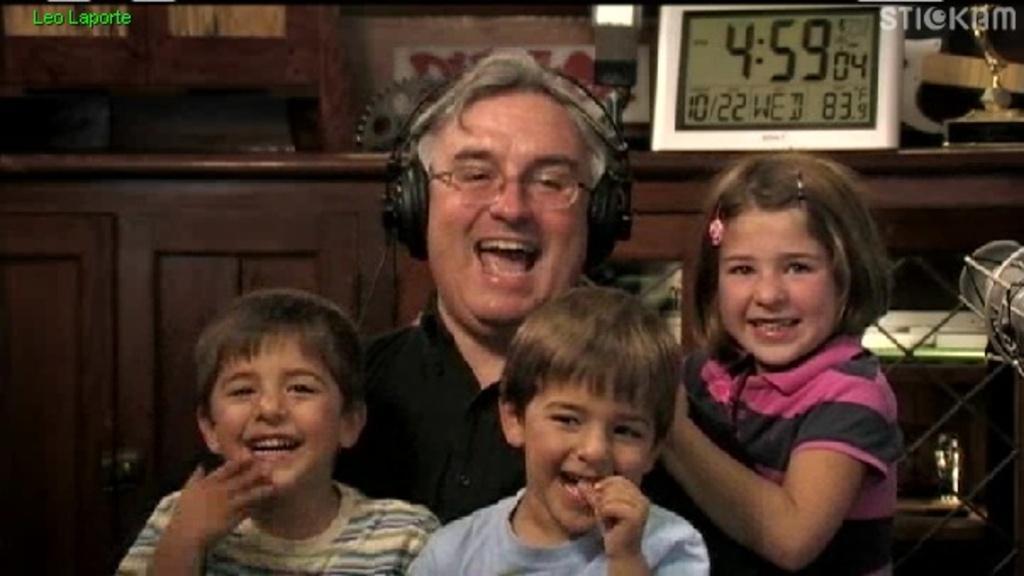Describe this image in one or two sentences. This picture shows a man. He wore a headset and we see spectacles on his face and we see few kids and we see smile on their faces and a digital clock on the back and we see a table with cupboards and a memento on the table and we see text on the top left corner and a watermark on the top right corner of the picture. 